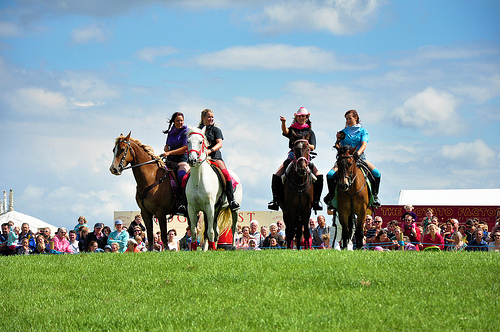<image>
Is the horse on the woman? Yes. Looking at the image, I can see the horse is positioned on top of the woman, with the woman providing support. Is the girl on the horse? Yes. Looking at the image, I can see the girl is positioned on top of the horse, with the horse providing support. Is the man behind the horse? Yes. From this viewpoint, the man is positioned behind the horse, with the horse partially or fully occluding the man. Is the sign in front of the woman? No. The sign is not in front of the woman. The spatial positioning shows a different relationship between these objects. 